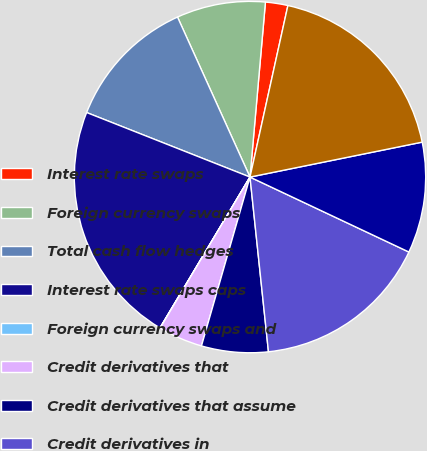Convert chart. <chart><loc_0><loc_0><loc_500><loc_500><pie_chart><fcel>Interest rate swaps<fcel>Foreign currency swaps<fcel>Total cash flow hedges<fcel>Interest rate swaps caps<fcel>Foreign currency swaps and<fcel>Credit derivatives that<fcel>Credit derivatives that assume<fcel>Credit derivatives in<fcel>Equity index swaps and options<fcel>GMWB hedging instruments<nl><fcel>2.06%<fcel>8.17%<fcel>12.24%<fcel>22.42%<fcel>0.02%<fcel>4.09%<fcel>6.13%<fcel>16.31%<fcel>10.2%<fcel>18.35%<nl></chart> 